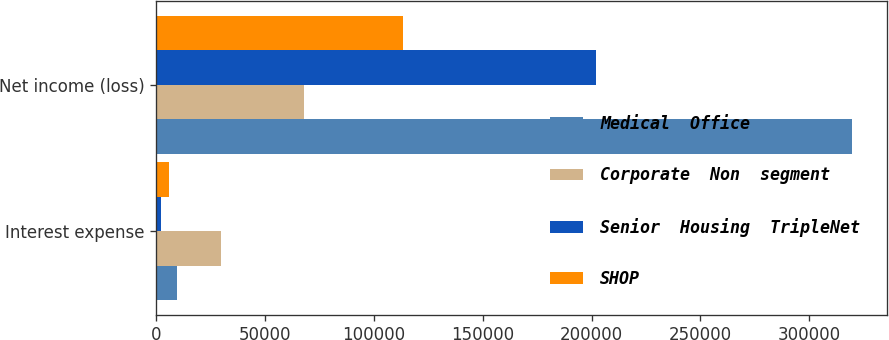Convert chart to OTSL. <chart><loc_0><loc_0><loc_500><loc_500><stacked_bar_chart><ecel><fcel>Interest expense<fcel>Net income (loss)<nl><fcel>Medical  Office<fcel>9499<fcel>319507<nl><fcel>Corporate  Non  segment<fcel>29745<fcel>68076<nl><fcel>Senior  Housing  TripleNet<fcel>2357<fcel>201915<nl><fcel>SHOP<fcel>5895<fcel>113241<nl></chart> 